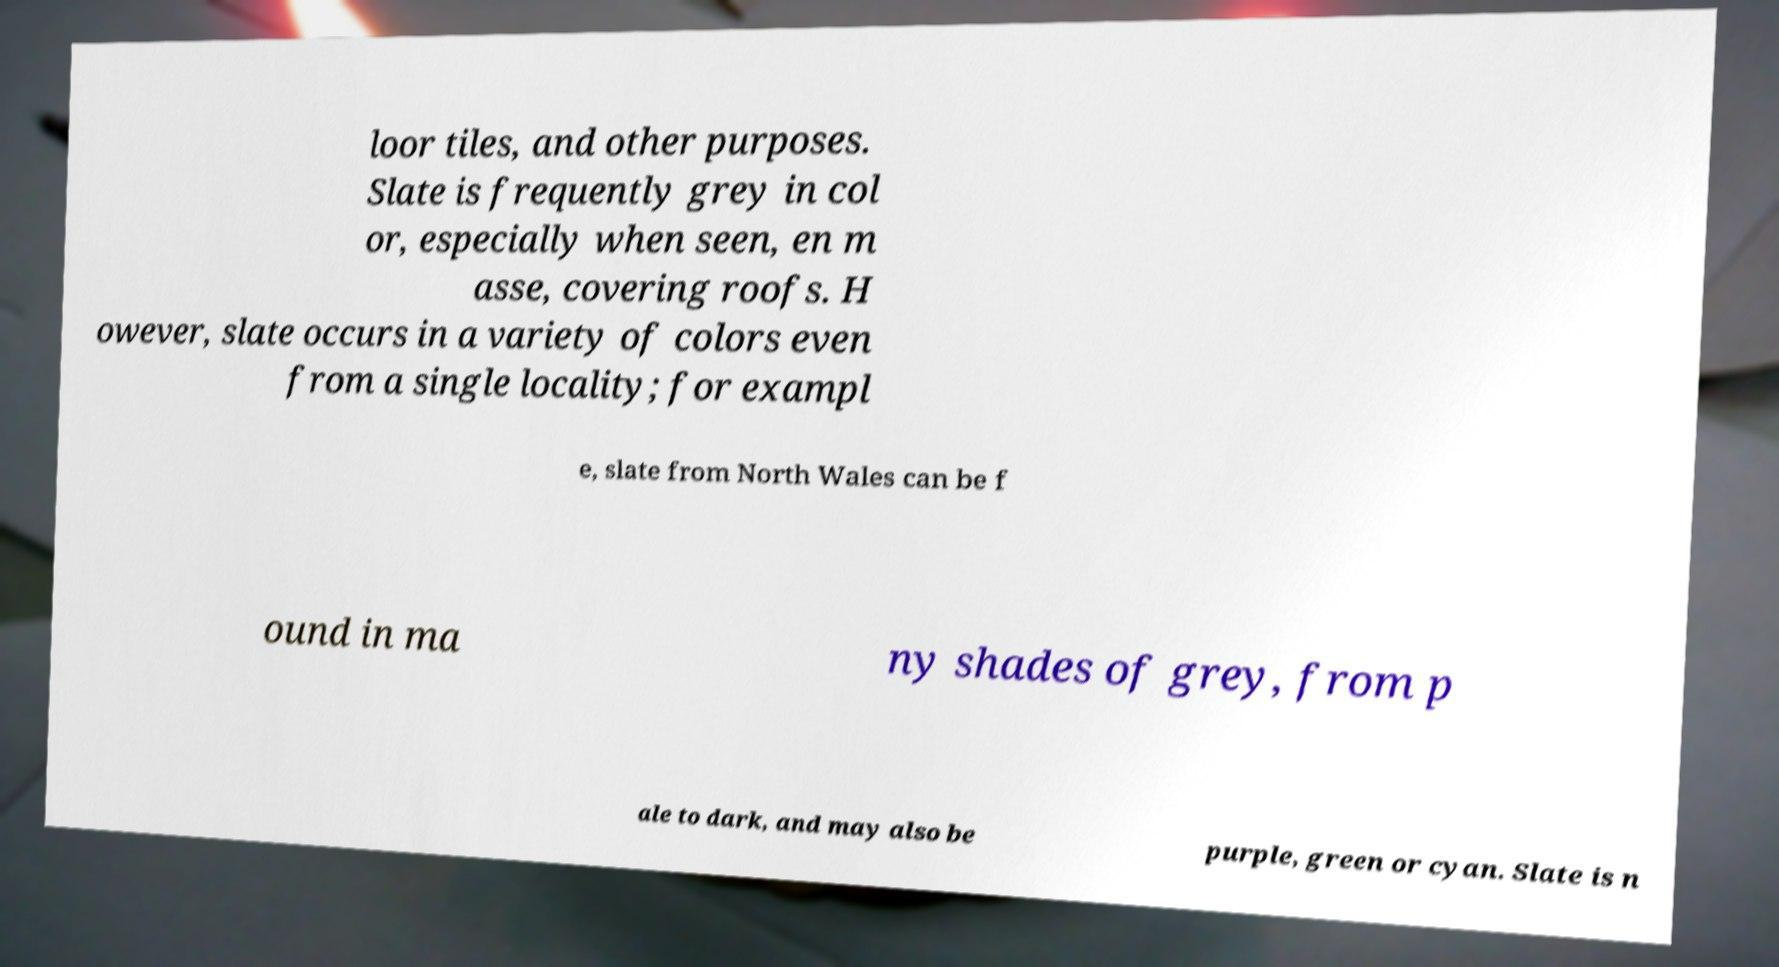What messages or text are displayed in this image? I need them in a readable, typed format. loor tiles, and other purposes. Slate is frequently grey in col or, especially when seen, en m asse, covering roofs. H owever, slate occurs in a variety of colors even from a single locality; for exampl e, slate from North Wales can be f ound in ma ny shades of grey, from p ale to dark, and may also be purple, green or cyan. Slate is n 